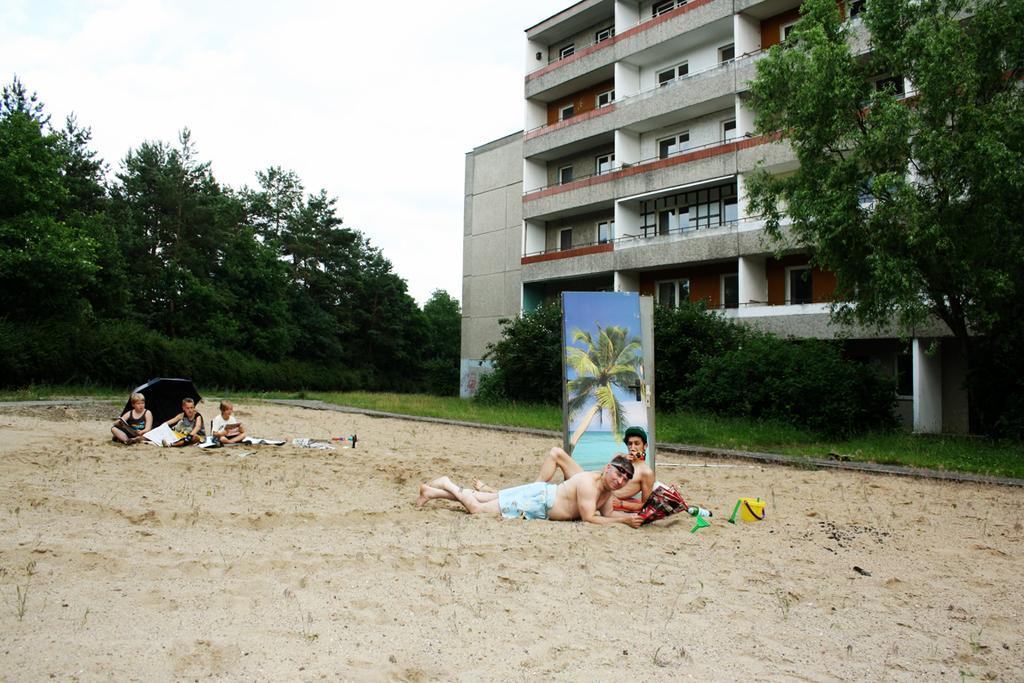Could you give a brief overview of what you see in this image? In this image I can see a building , in front of the building I can see trees on the right side and I can see three persons sitting on the ground beside that persons I can see an umbrella and I can see two persons lying on the ground in the middle , beside that persons I can see a board and I can see trees and the sky on the left side. 